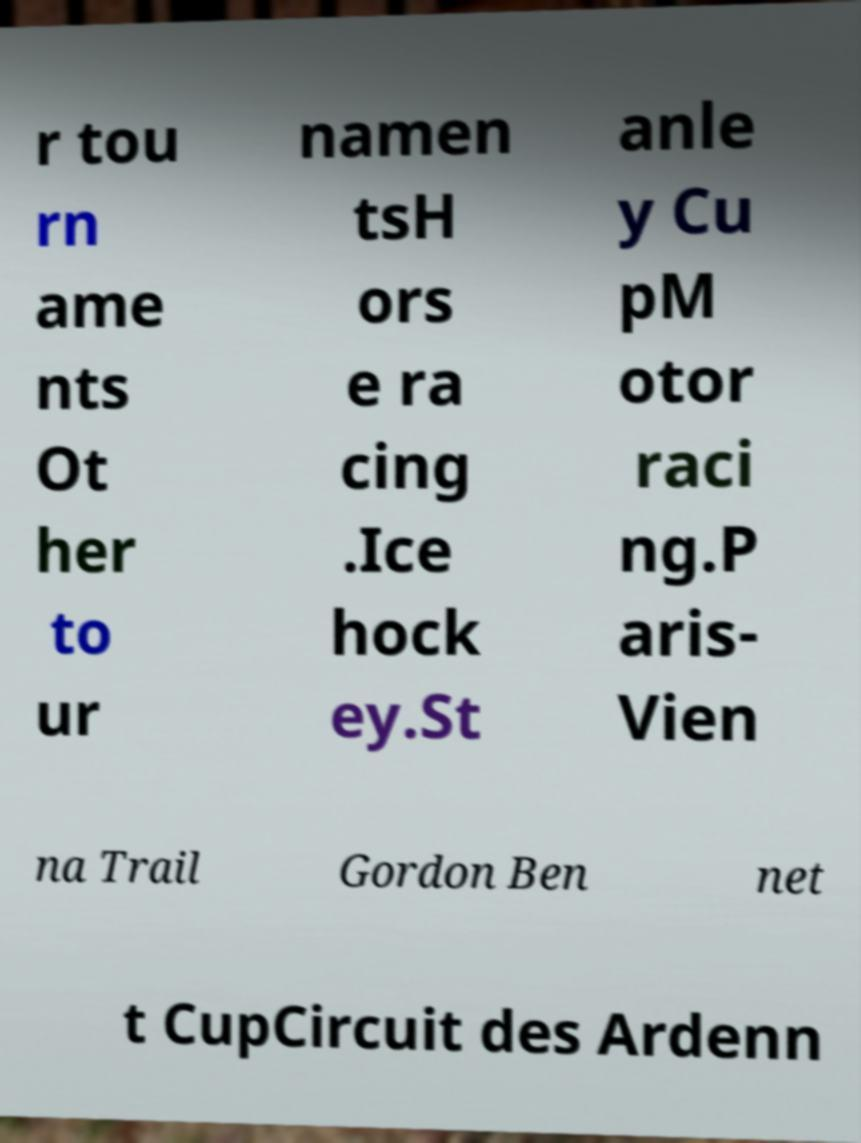Please identify and transcribe the text found in this image. r tou rn ame nts Ot her to ur namen tsH ors e ra cing .Ice hock ey.St anle y Cu pM otor raci ng.P aris- Vien na Trail Gordon Ben net t CupCircuit des Ardenn 